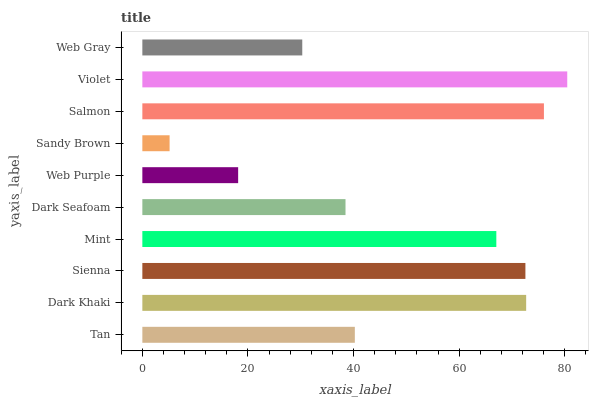Is Sandy Brown the minimum?
Answer yes or no. Yes. Is Violet the maximum?
Answer yes or no. Yes. Is Dark Khaki the minimum?
Answer yes or no. No. Is Dark Khaki the maximum?
Answer yes or no. No. Is Dark Khaki greater than Tan?
Answer yes or no. Yes. Is Tan less than Dark Khaki?
Answer yes or no. Yes. Is Tan greater than Dark Khaki?
Answer yes or no. No. Is Dark Khaki less than Tan?
Answer yes or no. No. Is Mint the high median?
Answer yes or no. Yes. Is Tan the low median?
Answer yes or no. Yes. Is Dark Khaki the high median?
Answer yes or no. No. Is Sienna the low median?
Answer yes or no. No. 